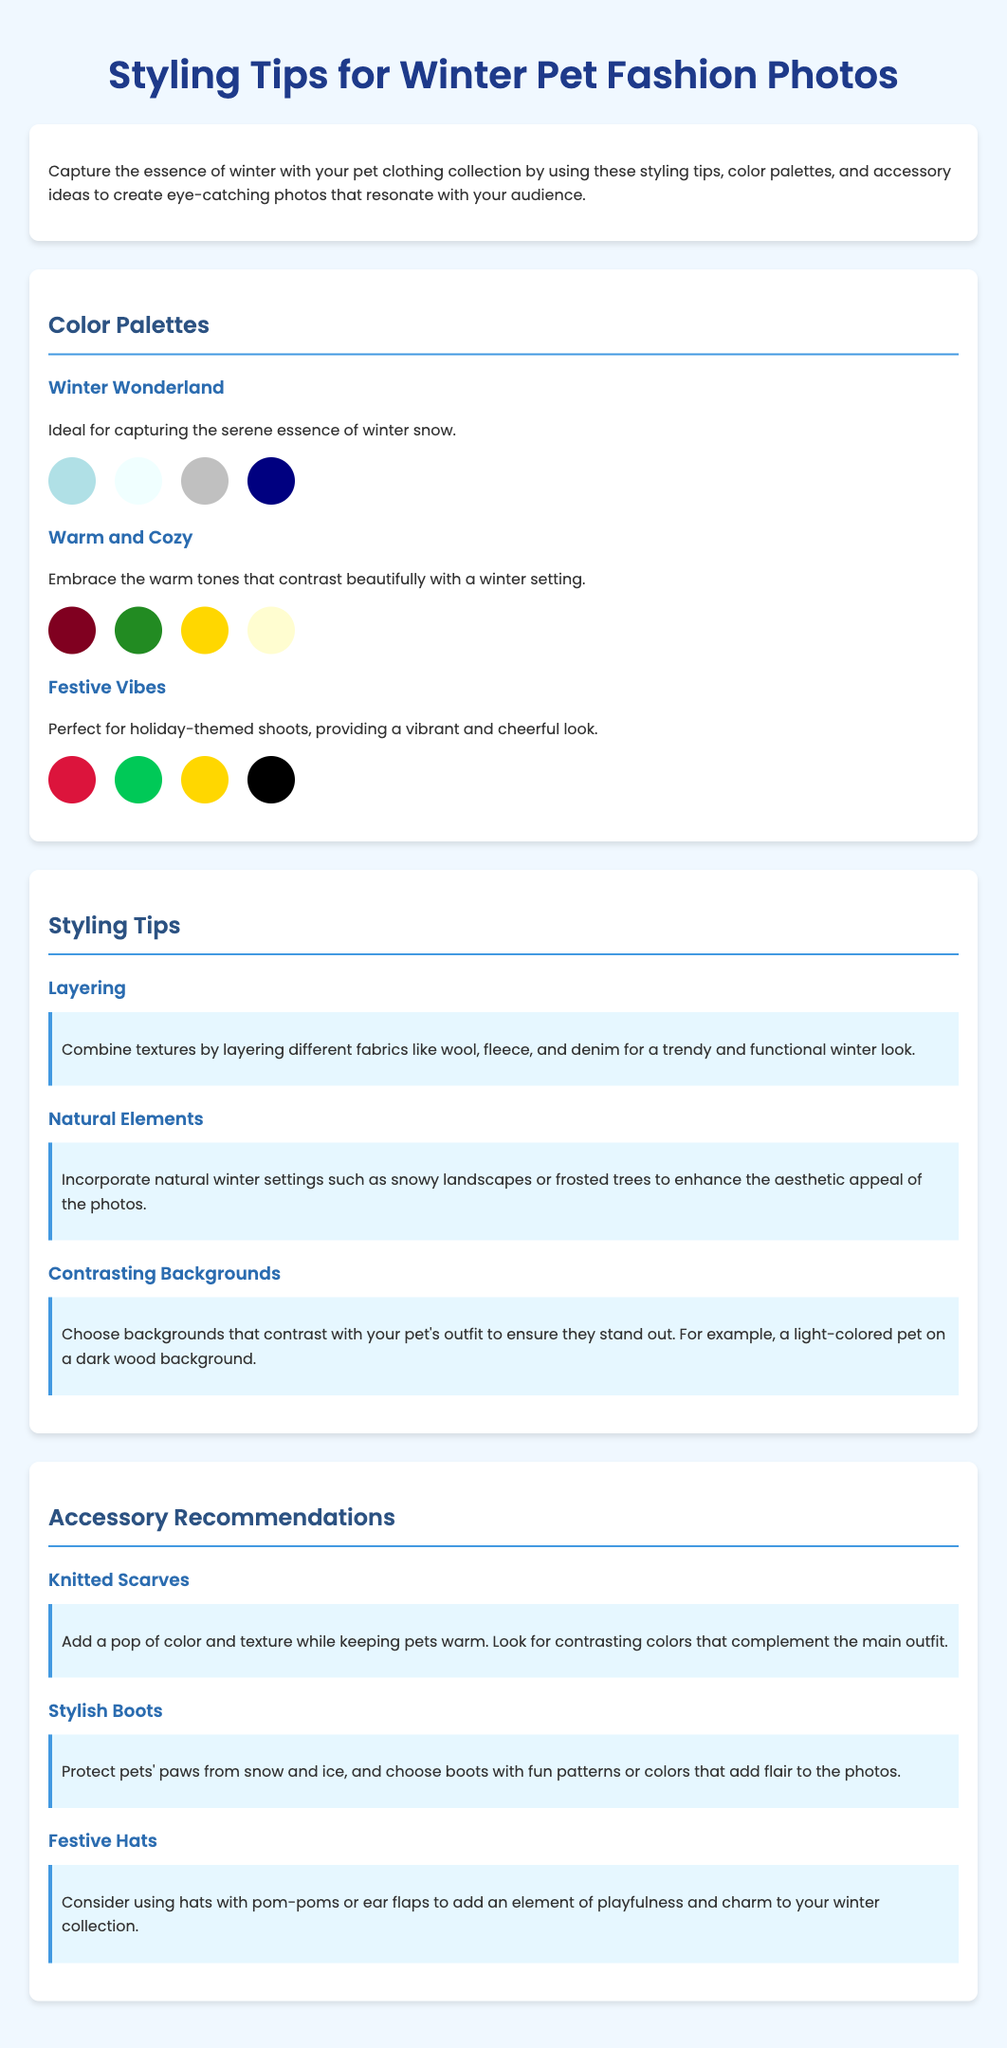What is the title of the document? The title appears at the top of the document, clearly stated as "Styling Tips for Winter Pet Fashion Photos."
Answer: Styling Tips for Winter Pet Fashion Photos How many color palettes are mentioned? The document lists three different color palettes under the "Color Palettes" section.
Answer: 3 What color is associated with the "Winter Wonderland" palette? Each palette includes multiple colors, and the first color in the "Winter Wonderland" palette is light blue (#B0E0E6).
Answer: light blue What is a recommended accessory for winter pet fashion? The document specifically recommends "Knitted Scarves" as an accessory.
Answer: Knitted Scarves What is the key styling tip provided for backgrounds? The document notes that backgrounds should contrast with the pet's outfit, enhancing their visibility in photos.
Answer: Contrasting backgrounds What is the purpose of the “Warm and Cozy” color palette? The description states that this palette embraces warm tones that contrast beautifully with a winter setting.
Answer: Embrace warm tones Which styling tip suggests using natural settings? The document mentions "Natural Elements" as a styling tip that incorporates natural winter settings.
Answer: Natural Elements How many accessory recommendations are provided? There are three specific accessory recommendations listed in the document.
Answer: 3 